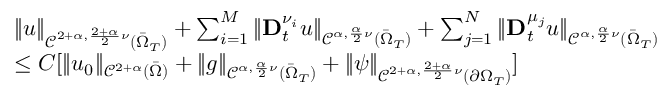Convert formula to latex. <formula><loc_0><loc_0><loc_500><loc_500>\begin{array} { r l } & { \| u \| _ { \mathcal { C } ^ { 2 + \alpha , \frac { 2 + \alpha } { 2 } \nu } ( \bar { \Omega } _ { T } ) } + \sum _ { i = 1 } ^ { M } \| D _ { t } ^ { \nu _ { i } } u \| _ { \mathcal { C } ^ { \alpha , \frac { \alpha } { 2 } \nu } ( \bar { \Omega } _ { T } ) } + \sum _ { j = 1 } ^ { N } \| D _ { t } ^ { \mu _ { j } } u \| _ { \mathcal { C } ^ { \alpha , \frac { \alpha } { 2 } \nu } ( \bar { \Omega } _ { T } ) } } \\ & { \leq C [ \| u _ { 0 } \| _ { \mathcal { C } ^ { 2 + \alpha } ( \bar { \Omega } ) } + \| g \| _ { \mathcal { C } ^ { \alpha , \frac { \alpha } { 2 } \nu } ( \bar { \Omega } _ { T } ) } + \| \psi \| _ { \mathcal { C } ^ { 2 + \alpha , \frac { 2 + \alpha } { 2 } \nu } ( \partial \Omega _ { T } ) } ] } \end{array}</formula> 